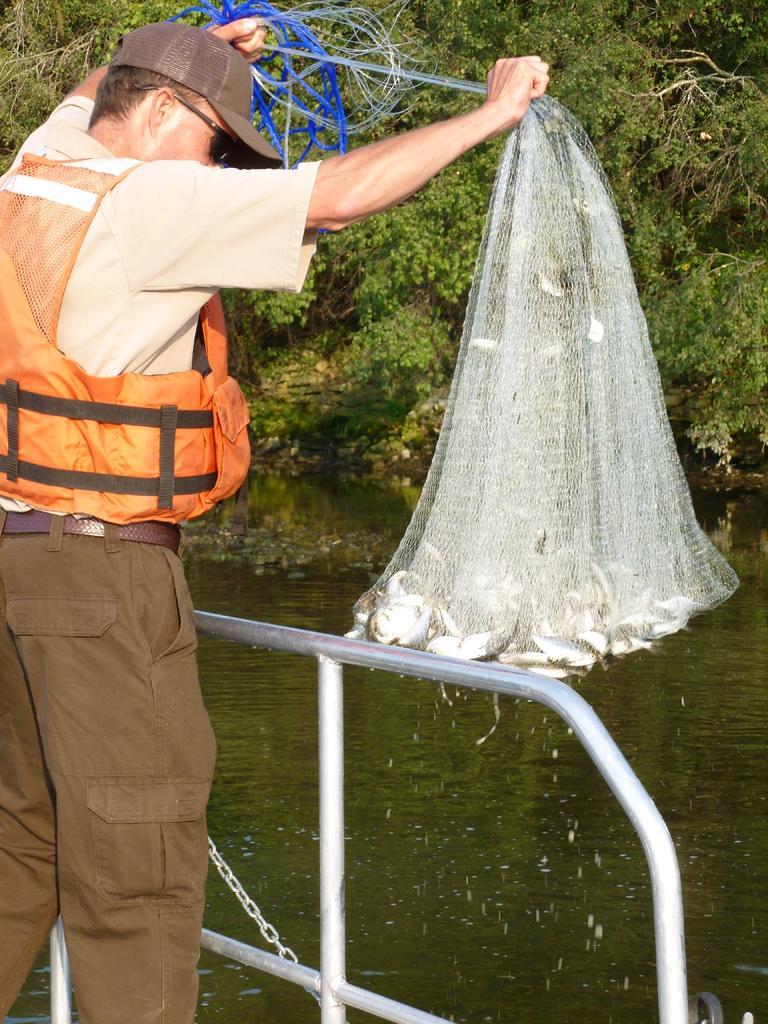Describe this image in one or two sentences. In the person wearing orange color jacket, glasses, cap and pant is holding a net in which we can see fishes are there and standing here. Here we can see water and trees in the background. 